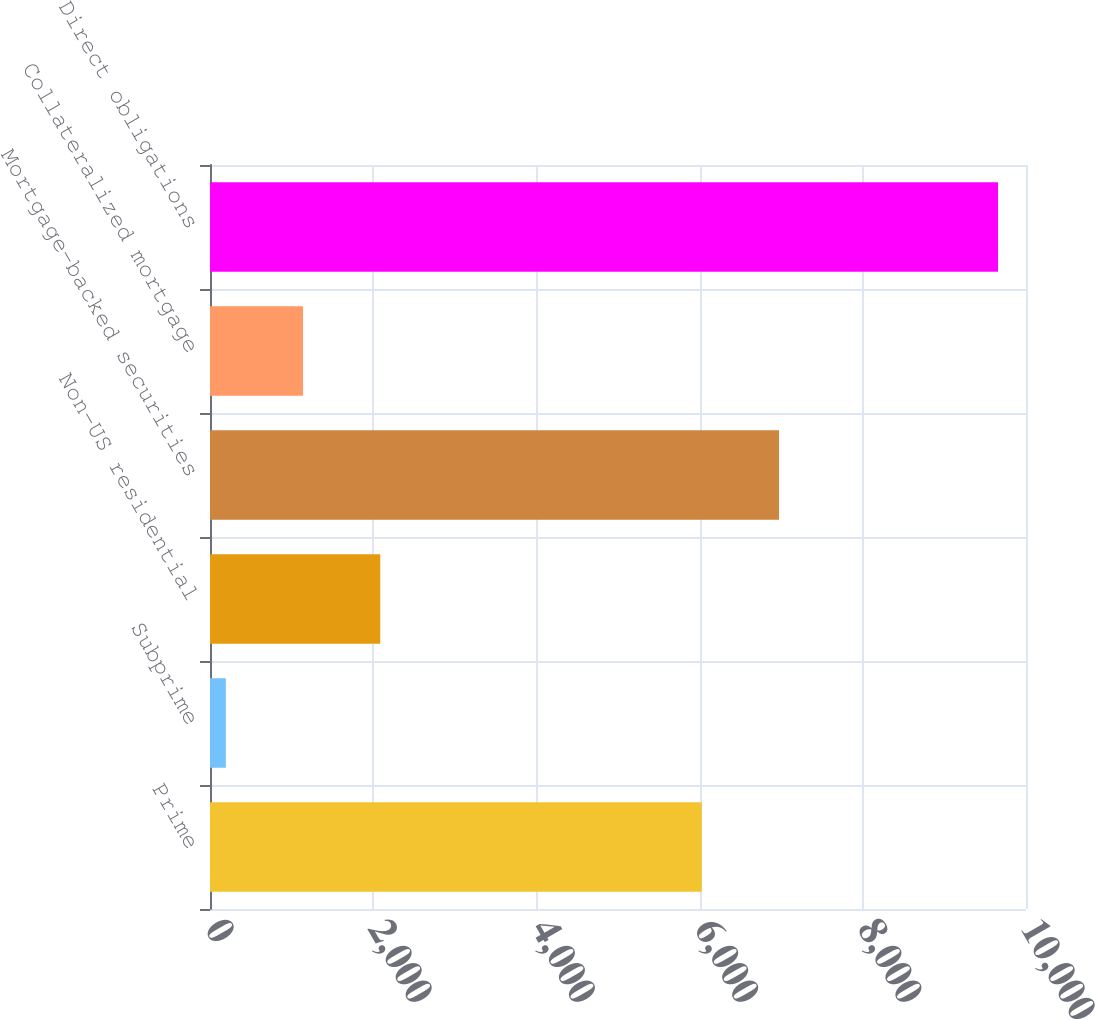Convert chart. <chart><loc_0><loc_0><loc_500><loc_500><bar_chart><fcel>Prime<fcel>Subprime<fcel>Non-US residential<fcel>Mortgage-backed securities<fcel>Collateralized mortgage<fcel>Direct obligations<nl><fcel>6027<fcel>194<fcel>2086.6<fcel>6973.3<fcel>1140.3<fcel>9657<nl></chart> 